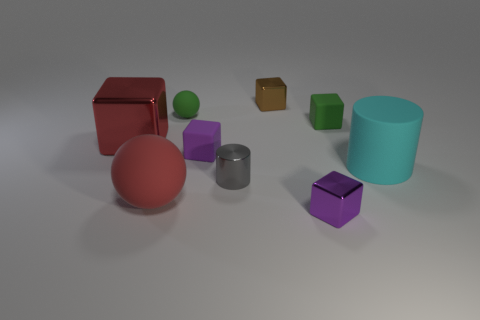Subtract all brown cubes. How many cubes are left? 4 Subtract all red cubes. How many cubes are left? 4 Subtract all gray cubes. Subtract all red balls. How many cubes are left? 5 Add 1 large yellow objects. How many objects exist? 10 Subtract all balls. How many objects are left? 7 Subtract all large cyan matte things. Subtract all big brown cylinders. How many objects are left? 8 Add 5 big balls. How many big balls are left? 6 Add 2 tiny gray objects. How many tiny gray objects exist? 3 Subtract 0 green cylinders. How many objects are left? 9 